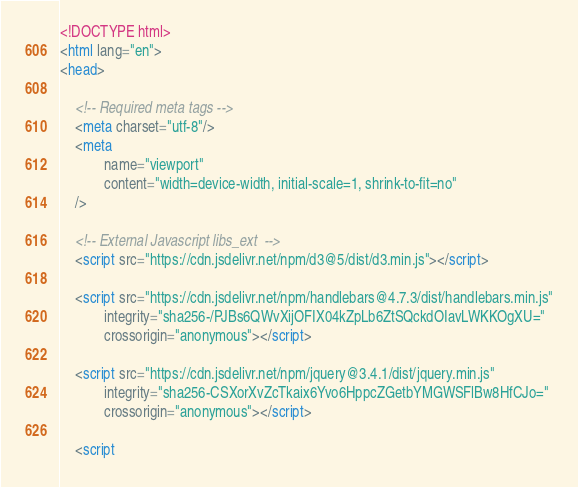Convert code to text. <code><loc_0><loc_0><loc_500><loc_500><_HTML_>


<!DOCTYPE html>
<html lang="en">
<head>
    
    <!-- Required meta tags -->
    <meta charset="utf-8"/>
    <meta
            name="viewport"
            content="width=device-width, initial-scale=1, shrink-to-fit=no"
    />

    <!-- External Javascript libs_ext  -->
    <script src="https://cdn.jsdelivr.net/npm/d3@5/dist/d3.min.js"></script>

    <script src="https://cdn.jsdelivr.net/npm/handlebars@4.7.3/dist/handlebars.min.js"
            integrity="sha256-/PJBs6QWvXijOFIX04kZpLb6ZtSQckdOIavLWKKOgXU="
            crossorigin="anonymous"></script>

    <script src="https://cdn.jsdelivr.net/npm/jquery@3.4.1/dist/jquery.min.js"
            integrity="sha256-CSXorXvZcTkaix6Yvo6HppcZGetbYMGWSFlBw8HfCJo="
            crossorigin="anonymous"></script>

    <script</code> 